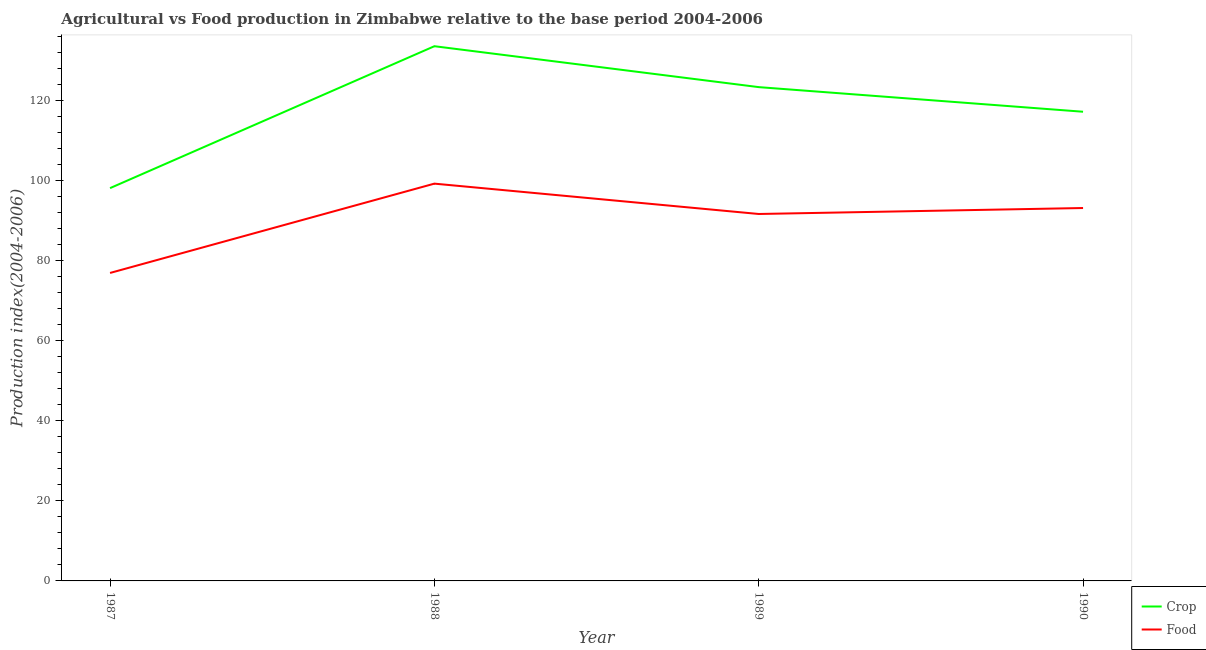How many different coloured lines are there?
Provide a succinct answer. 2. Does the line corresponding to crop production index intersect with the line corresponding to food production index?
Your response must be concise. No. What is the crop production index in 1989?
Your answer should be very brief. 123.35. Across all years, what is the maximum food production index?
Provide a short and direct response. 99.24. Across all years, what is the minimum crop production index?
Provide a succinct answer. 98.12. In which year was the crop production index minimum?
Offer a very short reply. 1987. What is the total food production index in the graph?
Your response must be concise. 360.98. What is the difference between the food production index in 1989 and that in 1990?
Ensure brevity in your answer.  -1.49. What is the difference between the crop production index in 1987 and the food production index in 1990?
Your answer should be compact. 4.97. What is the average crop production index per year?
Your answer should be very brief. 118.06. In the year 1987, what is the difference between the crop production index and food production index?
Make the answer very short. 21.19. In how many years, is the food production index greater than 48?
Provide a succinct answer. 4. What is the ratio of the crop production index in 1987 to that in 1988?
Your response must be concise. 0.73. Is the difference between the food production index in 1988 and 1989 greater than the difference between the crop production index in 1988 and 1989?
Your response must be concise. No. What is the difference between the highest and the second highest food production index?
Your response must be concise. 6.09. What is the difference between the highest and the lowest food production index?
Provide a short and direct response. 22.31. In how many years, is the food production index greater than the average food production index taken over all years?
Make the answer very short. 3. Is the sum of the food production index in 1988 and 1989 greater than the maximum crop production index across all years?
Your answer should be very brief. Yes. Does the crop production index monotonically increase over the years?
Provide a succinct answer. No. How many years are there in the graph?
Give a very brief answer. 4. What is the difference between two consecutive major ticks on the Y-axis?
Your response must be concise. 20. Does the graph contain any zero values?
Ensure brevity in your answer.  No. Where does the legend appear in the graph?
Your response must be concise. Bottom right. How are the legend labels stacked?
Ensure brevity in your answer.  Vertical. What is the title of the graph?
Give a very brief answer. Agricultural vs Food production in Zimbabwe relative to the base period 2004-2006. Does "Female" appear as one of the legend labels in the graph?
Ensure brevity in your answer.  No. What is the label or title of the X-axis?
Offer a very short reply. Year. What is the label or title of the Y-axis?
Your response must be concise. Production index(2004-2006). What is the Production index(2004-2006) in Crop in 1987?
Provide a short and direct response. 98.12. What is the Production index(2004-2006) in Food in 1987?
Your answer should be compact. 76.93. What is the Production index(2004-2006) in Crop in 1988?
Give a very brief answer. 133.57. What is the Production index(2004-2006) of Food in 1988?
Provide a succinct answer. 99.24. What is the Production index(2004-2006) in Crop in 1989?
Your answer should be very brief. 123.35. What is the Production index(2004-2006) in Food in 1989?
Provide a succinct answer. 91.66. What is the Production index(2004-2006) in Crop in 1990?
Offer a terse response. 117.2. What is the Production index(2004-2006) of Food in 1990?
Your answer should be very brief. 93.15. Across all years, what is the maximum Production index(2004-2006) in Crop?
Provide a short and direct response. 133.57. Across all years, what is the maximum Production index(2004-2006) in Food?
Keep it short and to the point. 99.24. Across all years, what is the minimum Production index(2004-2006) in Crop?
Your answer should be compact. 98.12. Across all years, what is the minimum Production index(2004-2006) in Food?
Keep it short and to the point. 76.93. What is the total Production index(2004-2006) of Crop in the graph?
Ensure brevity in your answer.  472.24. What is the total Production index(2004-2006) of Food in the graph?
Offer a terse response. 360.98. What is the difference between the Production index(2004-2006) of Crop in 1987 and that in 1988?
Offer a very short reply. -35.45. What is the difference between the Production index(2004-2006) in Food in 1987 and that in 1988?
Your answer should be very brief. -22.31. What is the difference between the Production index(2004-2006) of Crop in 1987 and that in 1989?
Offer a very short reply. -25.23. What is the difference between the Production index(2004-2006) of Food in 1987 and that in 1989?
Ensure brevity in your answer.  -14.73. What is the difference between the Production index(2004-2006) of Crop in 1987 and that in 1990?
Offer a very short reply. -19.08. What is the difference between the Production index(2004-2006) in Food in 1987 and that in 1990?
Your response must be concise. -16.22. What is the difference between the Production index(2004-2006) in Crop in 1988 and that in 1989?
Provide a succinct answer. 10.22. What is the difference between the Production index(2004-2006) of Food in 1988 and that in 1989?
Your answer should be compact. 7.58. What is the difference between the Production index(2004-2006) of Crop in 1988 and that in 1990?
Your answer should be compact. 16.37. What is the difference between the Production index(2004-2006) of Food in 1988 and that in 1990?
Provide a succinct answer. 6.09. What is the difference between the Production index(2004-2006) in Crop in 1989 and that in 1990?
Your response must be concise. 6.15. What is the difference between the Production index(2004-2006) of Food in 1989 and that in 1990?
Provide a short and direct response. -1.49. What is the difference between the Production index(2004-2006) in Crop in 1987 and the Production index(2004-2006) in Food in 1988?
Your answer should be very brief. -1.12. What is the difference between the Production index(2004-2006) of Crop in 1987 and the Production index(2004-2006) of Food in 1989?
Ensure brevity in your answer.  6.46. What is the difference between the Production index(2004-2006) in Crop in 1987 and the Production index(2004-2006) in Food in 1990?
Your response must be concise. 4.97. What is the difference between the Production index(2004-2006) of Crop in 1988 and the Production index(2004-2006) of Food in 1989?
Your answer should be compact. 41.91. What is the difference between the Production index(2004-2006) of Crop in 1988 and the Production index(2004-2006) of Food in 1990?
Keep it short and to the point. 40.42. What is the difference between the Production index(2004-2006) in Crop in 1989 and the Production index(2004-2006) in Food in 1990?
Make the answer very short. 30.2. What is the average Production index(2004-2006) in Crop per year?
Your answer should be compact. 118.06. What is the average Production index(2004-2006) of Food per year?
Your answer should be very brief. 90.25. In the year 1987, what is the difference between the Production index(2004-2006) of Crop and Production index(2004-2006) of Food?
Your response must be concise. 21.19. In the year 1988, what is the difference between the Production index(2004-2006) of Crop and Production index(2004-2006) of Food?
Your answer should be very brief. 34.33. In the year 1989, what is the difference between the Production index(2004-2006) in Crop and Production index(2004-2006) in Food?
Provide a short and direct response. 31.69. In the year 1990, what is the difference between the Production index(2004-2006) of Crop and Production index(2004-2006) of Food?
Provide a short and direct response. 24.05. What is the ratio of the Production index(2004-2006) of Crop in 1987 to that in 1988?
Keep it short and to the point. 0.73. What is the ratio of the Production index(2004-2006) of Food in 1987 to that in 1988?
Keep it short and to the point. 0.78. What is the ratio of the Production index(2004-2006) of Crop in 1987 to that in 1989?
Give a very brief answer. 0.8. What is the ratio of the Production index(2004-2006) in Food in 1987 to that in 1989?
Ensure brevity in your answer.  0.84. What is the ratio of the Production index(2004-2006) of Crop in 1987 to that in 1990?
Your answer should be very brief. 0.84. What is the ratio of the Production index(2004-2006) in Food in 1987 to that in 1990?
Your response must be concise. 0.83. What is the ratio of the Production index(2004-2006) in Crop in 1988 to that in 1989?
Provide a succinct answer. 1.08. What is the ratio of the Production index(2004-2006) of Food in 1988 to that in 1989?
Keep it short and to the point. 1.08. What is the ratio of the Production index(2004-2006) in Crop in 1988 to that in 1990?
Provide a short and direct response. 1.14. What is the ratio of the Production index(2004-2006) of Food in 1988 to that in 1990?
Make the answer very short. 1.07. What is the ratio of the Production index(2004-2006) in Crop in 1989 to that in 1990?
Provide a succinct answer. 1.05. What is the ratio of the Production index(2004-2006) in Food in 1989 to that in 1990?
Offer a very short reply. 0.98. What is the difference between the highest and the second highest Production index(2004-2006) in Crop?
Provide a short and direct response. 10.22. What is the difference between the highest and the second highest Production index(2004-2006) in Food?
Offer a very short reply. 6.09. What is the difference between the highest and the lowest Production index(2004-2006) of Crop?
Ensure brevity in your answer.  35.45. What is the difference between the highest and the lowest Production index(2004-2006) of Food?
Provide a short and direct response. 22.31. 